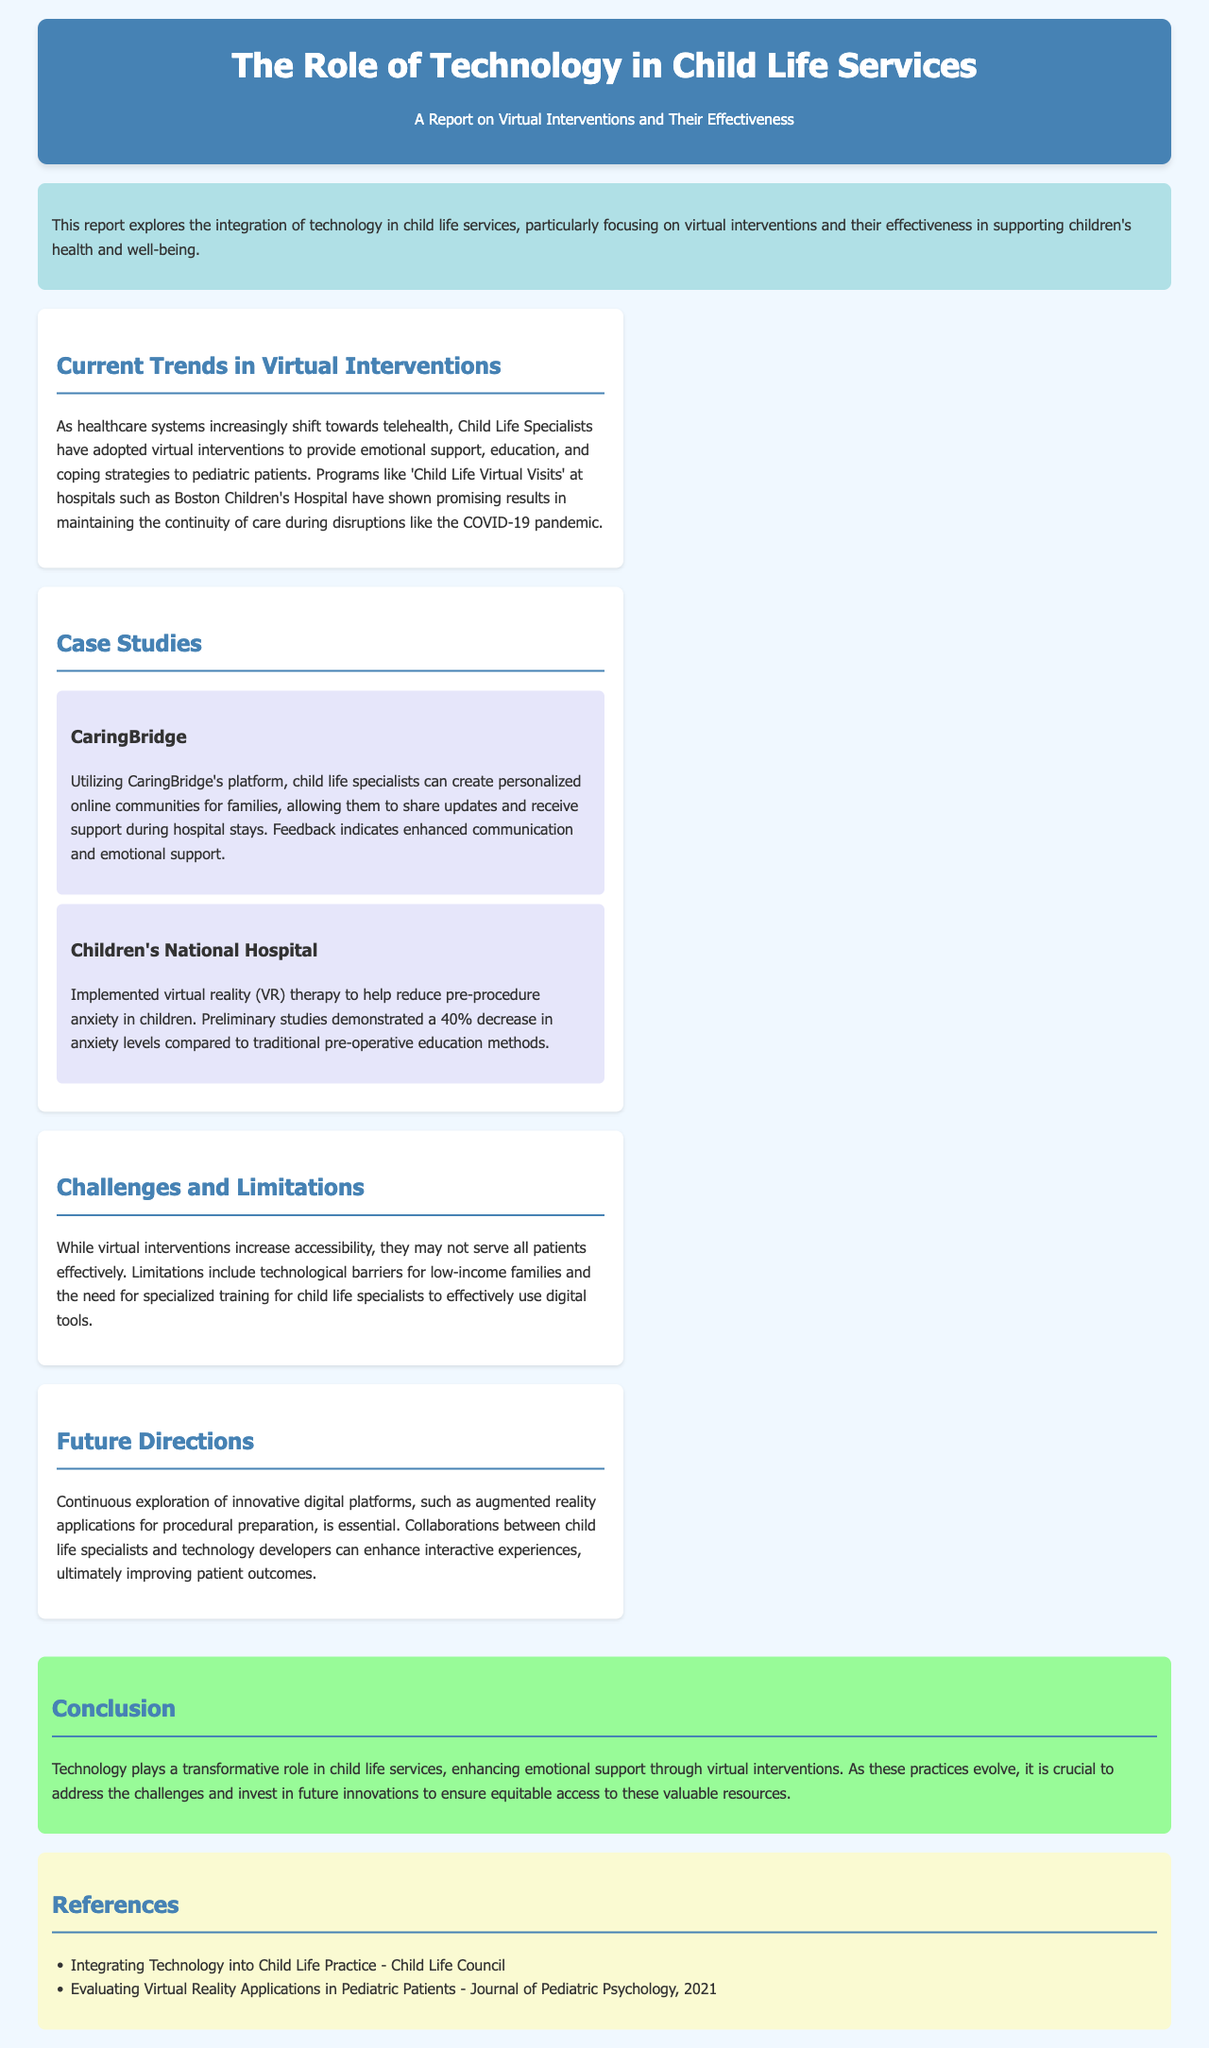What is the focus of the report? The report explores the integration of technology in child life services, particularly focusing on virtual interventions and their effectiveness in supporting children's health and well-being.
Answer: Virtual interventions What percentage decrease in anxiety levels was demonstrated using VR therapy? Preliminary studies at Children's National Hospital showed a 40% decrease in anxiety levels compared to traditional methods.
Answer: 40% Which program is mentioned at Boston Children's Hospital? The report references the 'Child Life Virtual Visits' program at Boston Children's Hospital as a promising example during the COVID-19 pandemic.
Answer: Child Life Virtual Visits What is one challenge of virtual interventions mentioned in the report? The report states that technological barriers for low-income families pose a challenge to effective virtual interventions.
Answer: Technological barriers What type of digital platforms are suggested for future exploration? The report suggests exploring innovative digital platforms such as augmented reality applications for procedural preparation in the future.
Answer: Augmented reality applications 